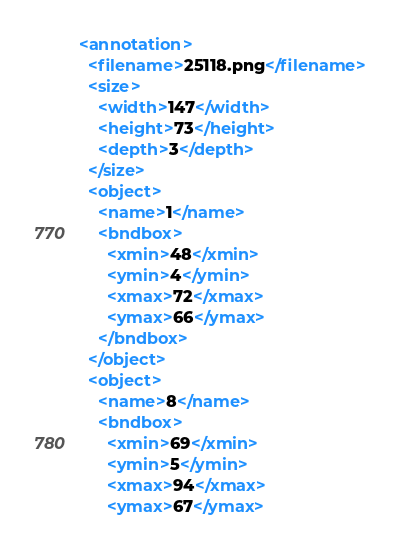Convert code to text. <code><loc_0><loc_0><loc_500><loc_500><_XML_><annotation>
  <filename>25118.png</filename>
  <size>
    <width>147</width>
    <height>73</height>
    <depth>3</depth>
  </size>
  <object>
    <name>1</name>
    <bndbox>
      <xmin>48</xmin>
      <ymin>4</ymin>
      <xmax>72</xmax>
      <ymax>66</ymax>
    </bndbox>
  </object>
  <object>
    <name>8</name>
    <bndbox>
      <xmin>69</xmin>
      <ymin>5</ymin>
      <xmax>94</xmax>
      <ymax>67</ymax></code> 